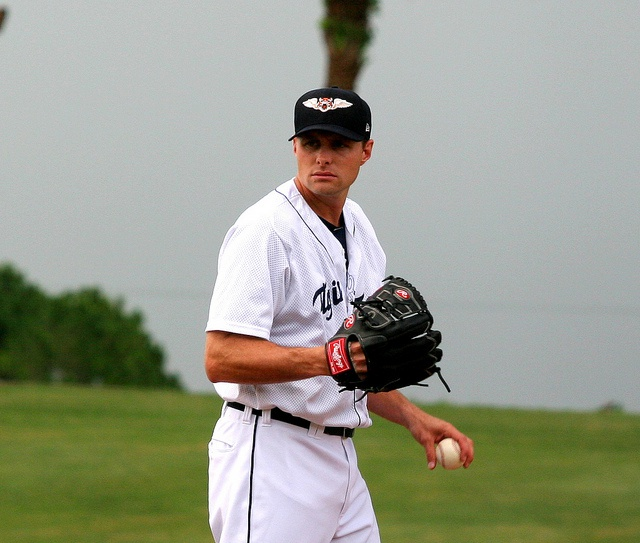Describe the objects in this image and their specific colors. I can see people in lightgray, lavender, black, darkgray, and maroon tones, baseball glove in lightgray, black, gray, darkgray, and maroon tones, and sports ball in lightgray, tan, gray, and brown tones in this image. 